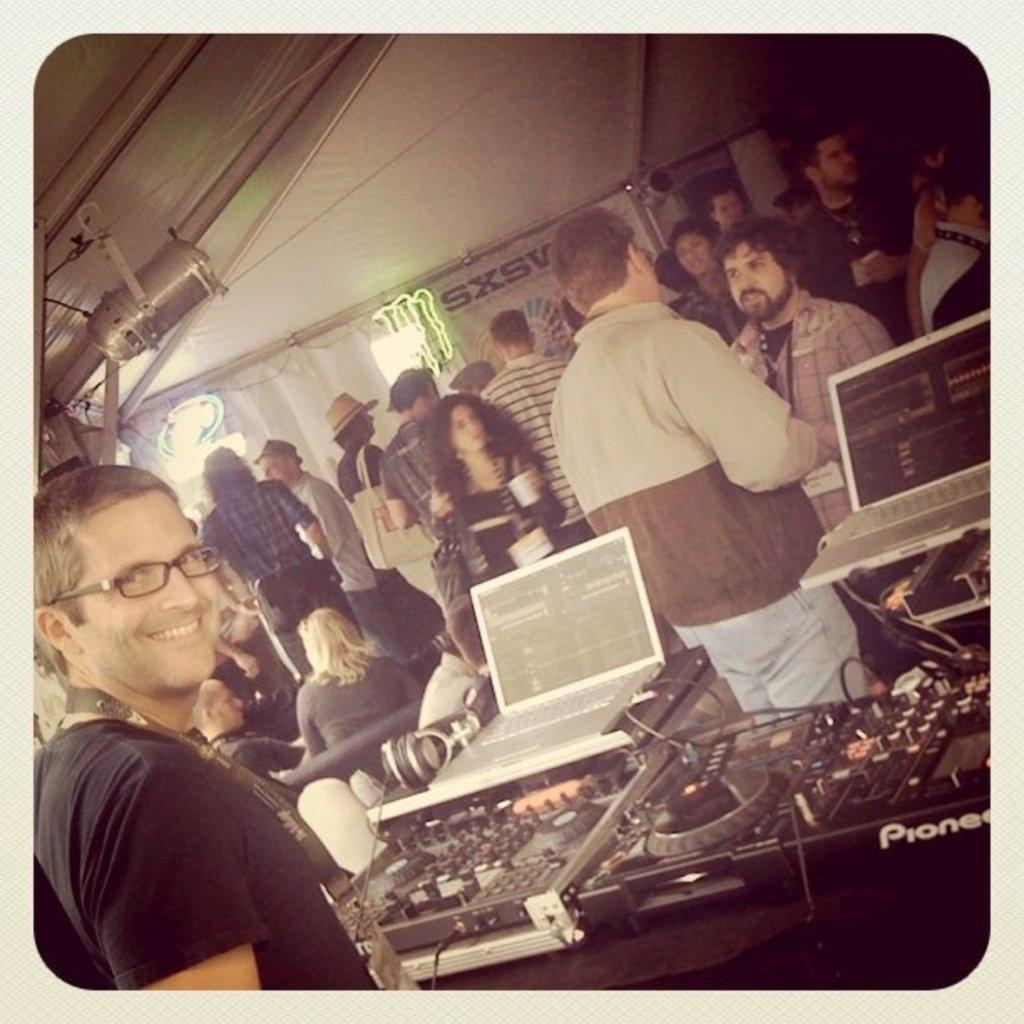How many people are visible in the image? There are people standing in the image. What is one person doing with an object? A person is holding an object. What type of furniture can be seen in the image? Two people are sitting on a couch. What type of electronic devices are present in the image? There are laptops and music players in the image. How many chickens are visible in the image? There are no chickens present in the image. What type of grape is being used as a decoration in the image? There is no grape present in the image. 